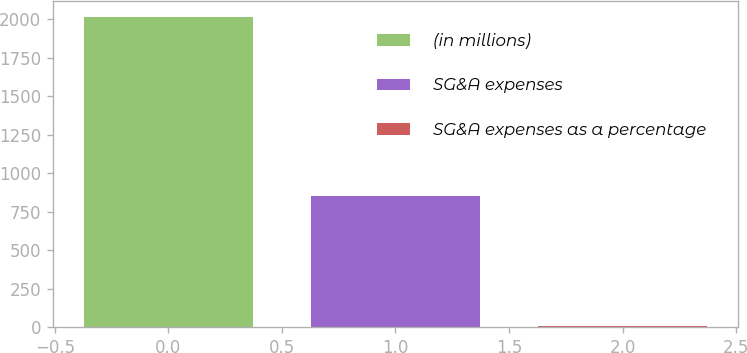<chart> <loc_0><loc_0><loc_500><loc_500><bar_chart><fcel>(in millions)<fcel>SG&A expenses<fcel>SG&A expenses as a percentage<nl><fcel>2017<fcel>850.2<fcel>9.3<nl></chart> 